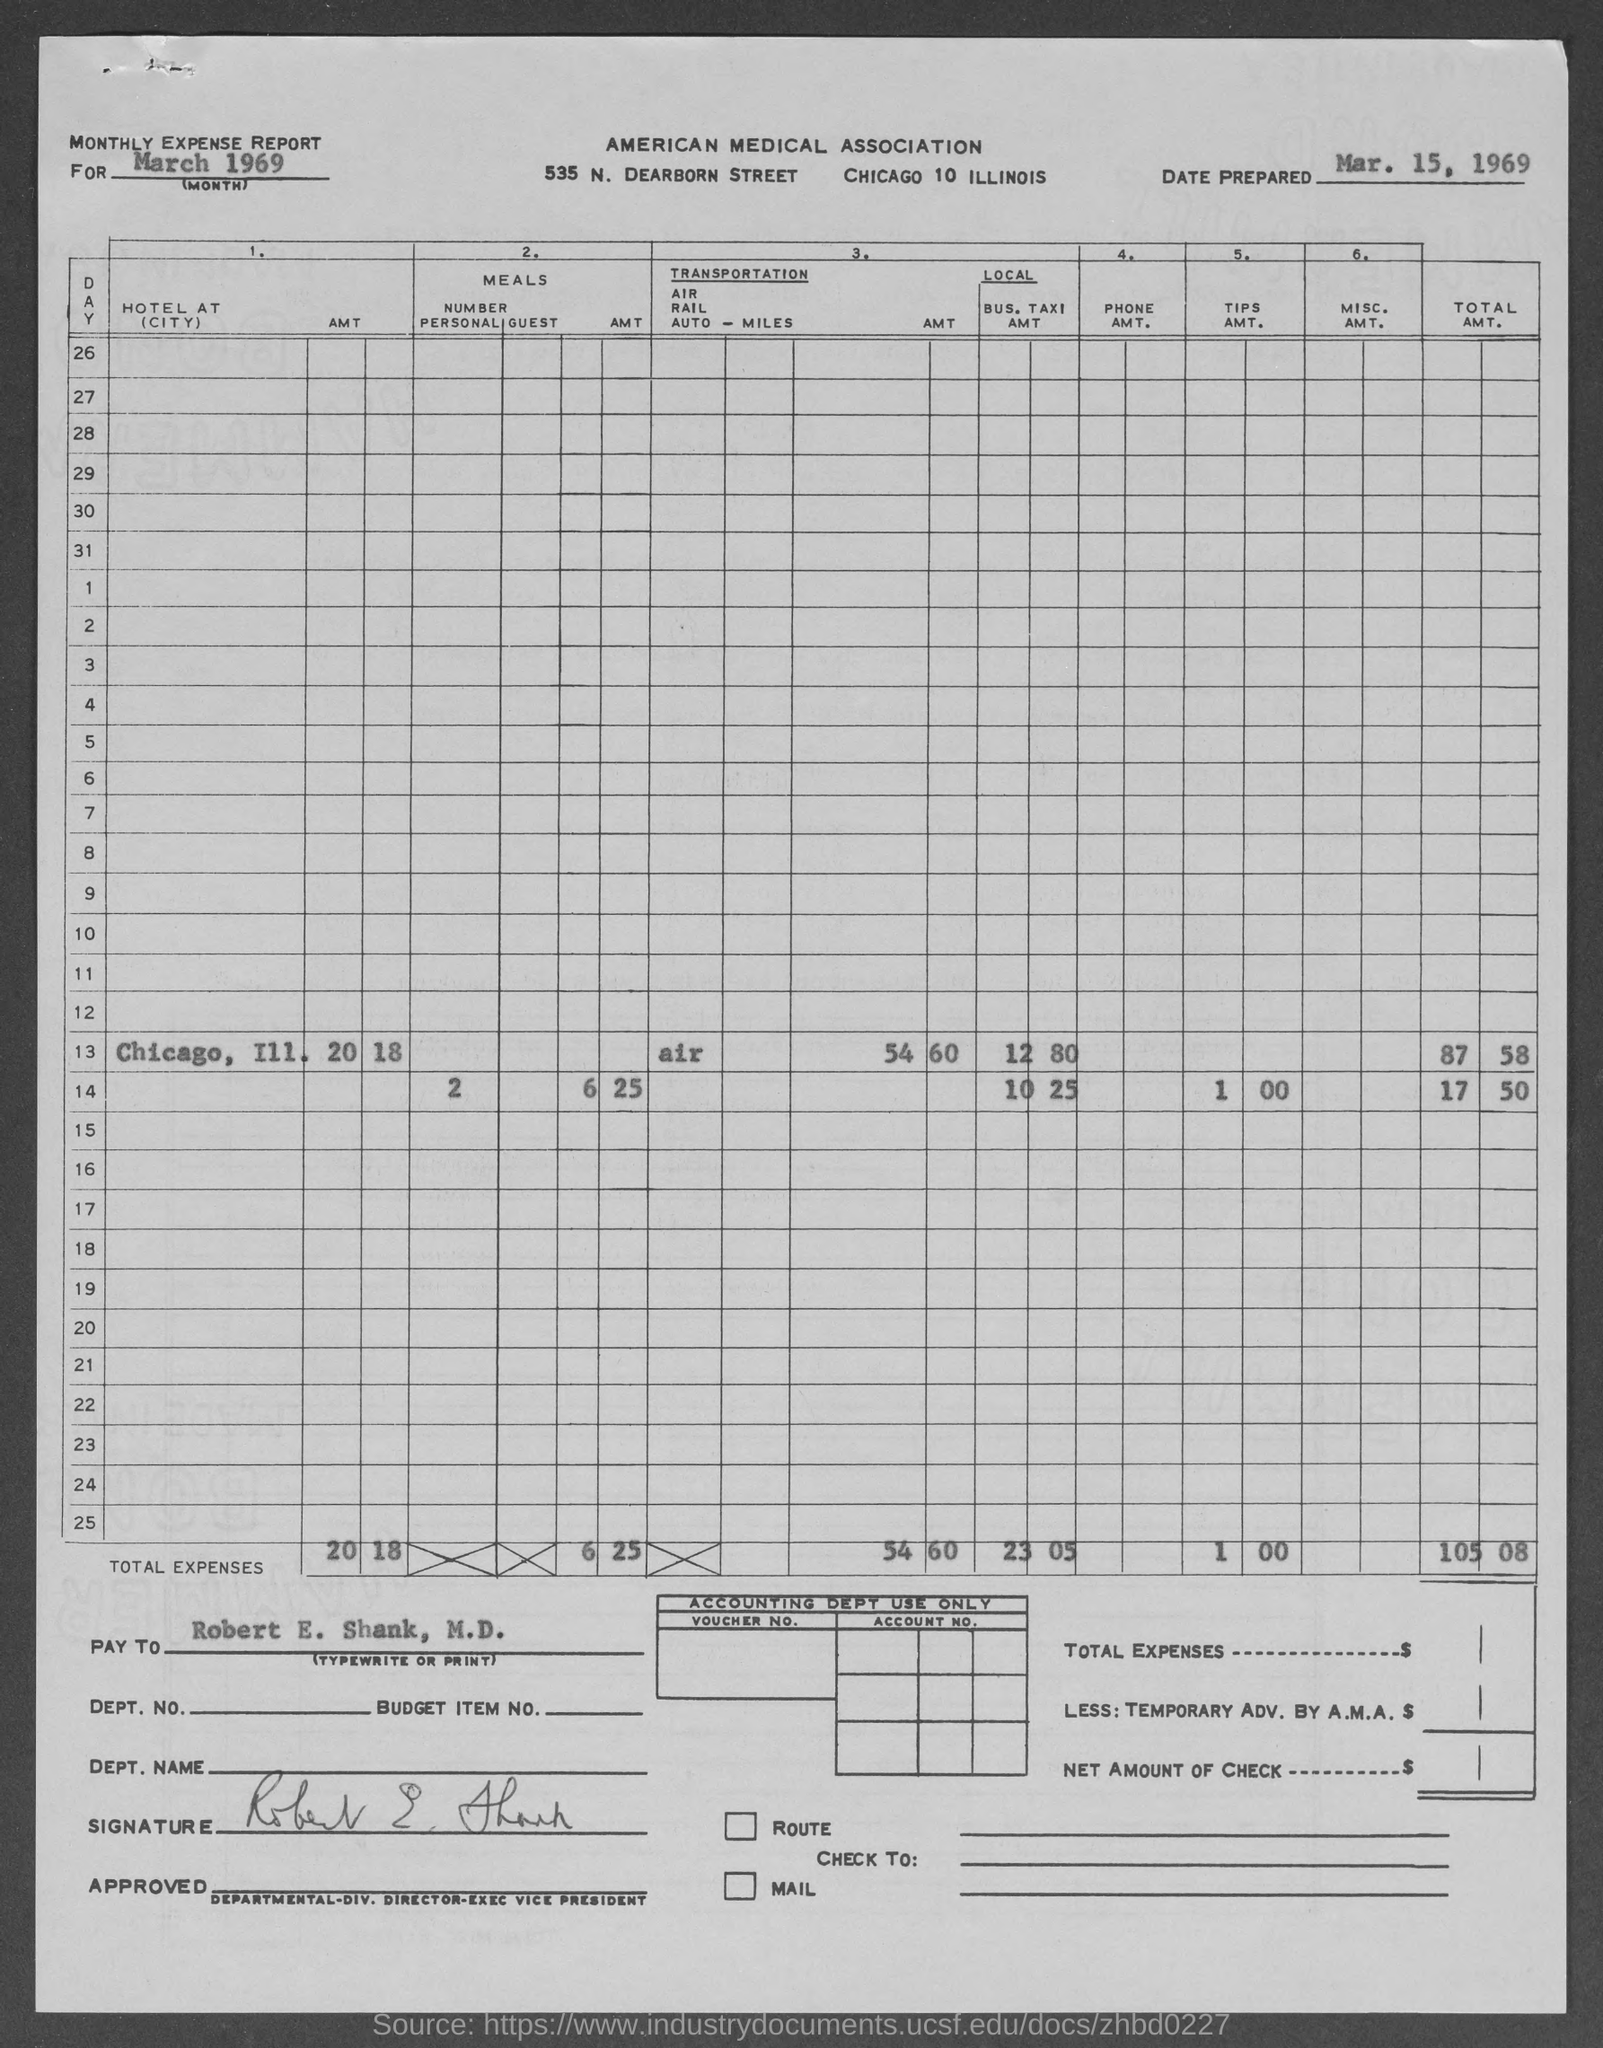What is the Date prepared as per the document?
Your response must be concise. MAR. 15, 1969. 